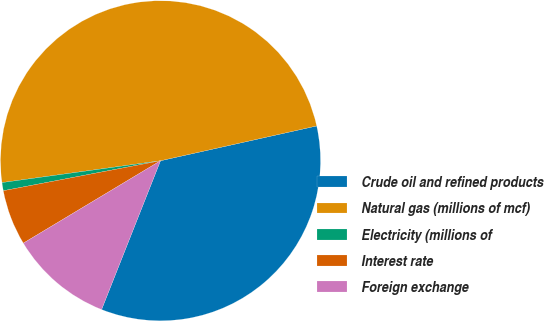<chart> <loc_0><loc_0><loc_500><loc_500><pie_chart><fcel>Crude oil and refined products<fcel>Natural gas (millions of mcf)<fcel>Electricity (millions of<fcel>Interest rate<fcel>Foreign exchange<nl><fcel>34.49%<fcel>48.69%<fcel>0.82%<fcel>5.61%<fcel>10.39%<nl></chart> 